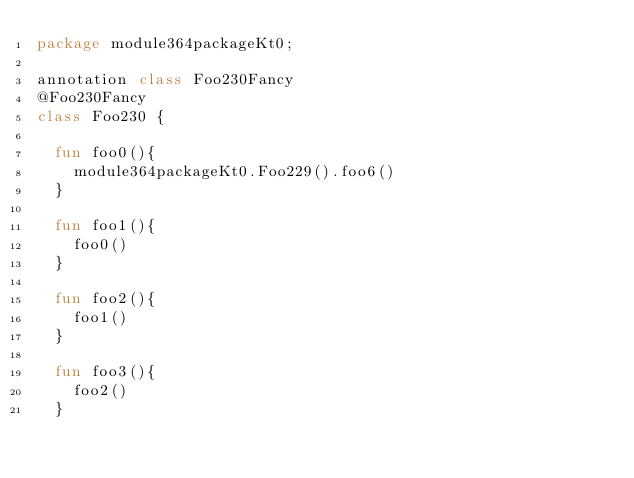Convert code to text. <code><loc_0><loc_0><loc_500><loc_500><_Kotlin_>package module364packageKt0;

annotation class Foo230Fancy
@Foo230Fancy
class Foo230 {

  fun foo0(){
    module364packageKt0.Foo229().foo6()
  }

  fun foo1(){
    foo0()
  }

  fun foo2(){
    foo1()
  }

  fun foo3(){
    foo2()
  }
</code> 